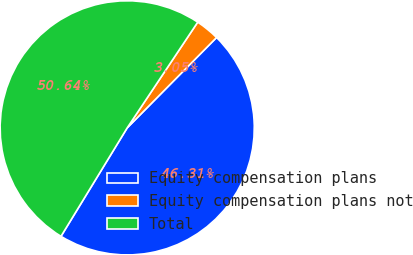Convert chart. <chart><loc_0><loc_0><loc_500><loc_500><pie_chart><fcel>Equity compensation plans<fcel>Equity compensation plans not<fcel>Total<nl><fcel>46.31%<fcel>3.05%<fcel>50.64%<nl></chart> 